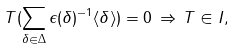Convert formula to latex. <formula><loc_0><loc_0><loc_500><loc_500>T ( \sum _ { \delta \in \Delta } \epsilon ( \delta ) ^ { - 1 } \langle \delta \rangle ) = 0 \, \Rightarrow \, T \in I ,</formula> 